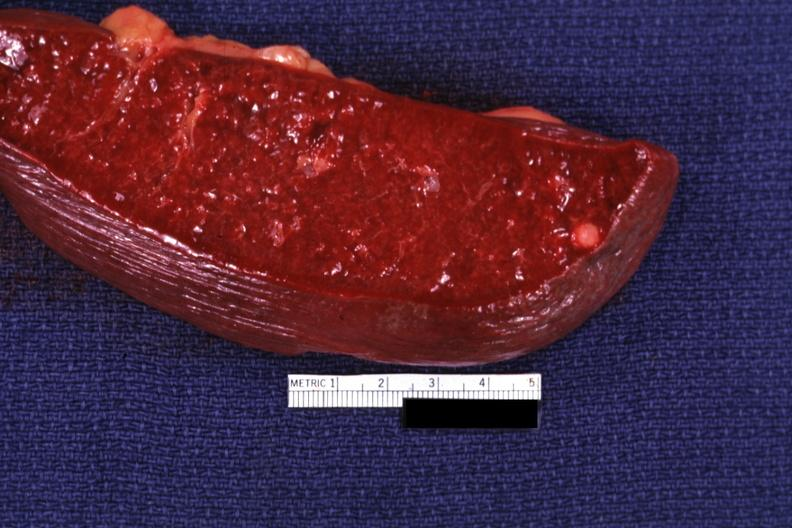where is this part in?
Answer the question using a single word or phrase. Spleen 